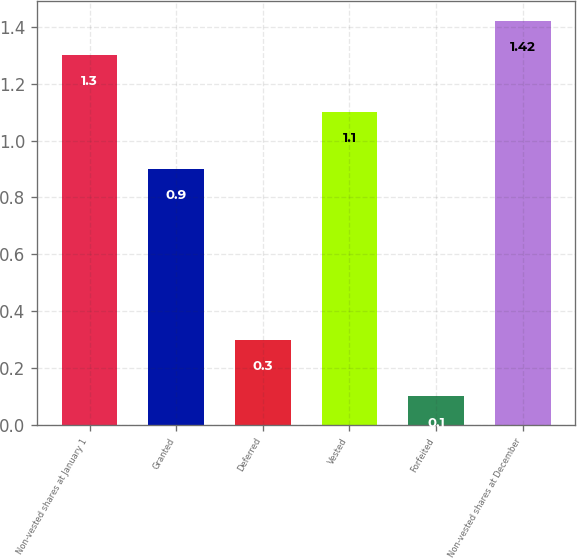<chart> <loc_0><loc_0><loc_500><loc_500><bar_chart><fcel>Non-vested shares at January 1<fcel>Granted<fcel>Deferred<fcel>Vested<fcel>Forfeited<fcel>Non-vested shares at December<nl><fcel>1.3<fcel>0.9<fcel>0.3<fcel>1.1<fcel>0.1<fcel>1.42<nl></chart> 